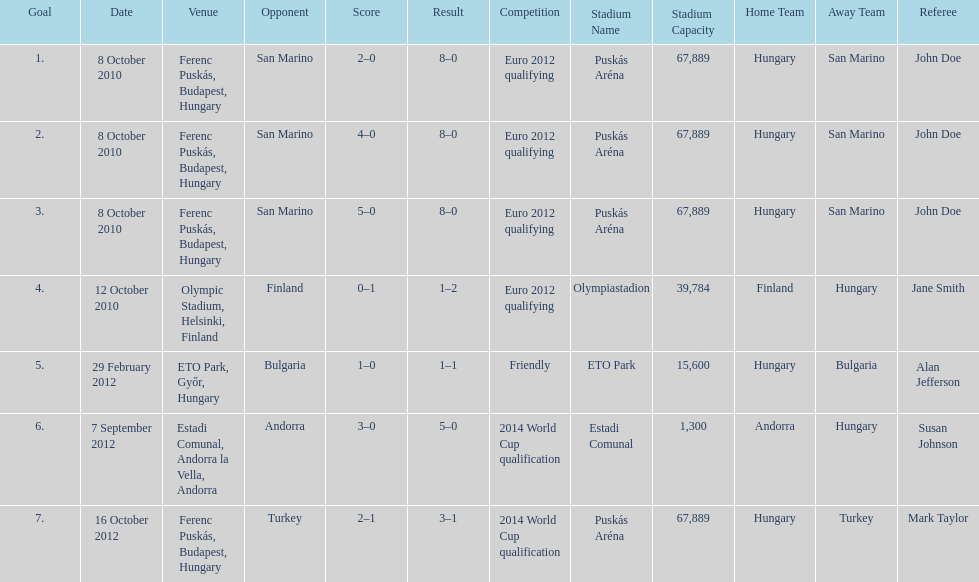When did ádám szalai make his first international goal? 8 October 2010. 